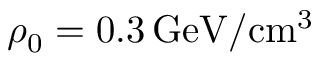<formula> <loc_0><loc_0><loc_500><loc_500>\rho _ { 0 } = 0 . 3 \, G e V / c m ^ { 3 }</formula> 